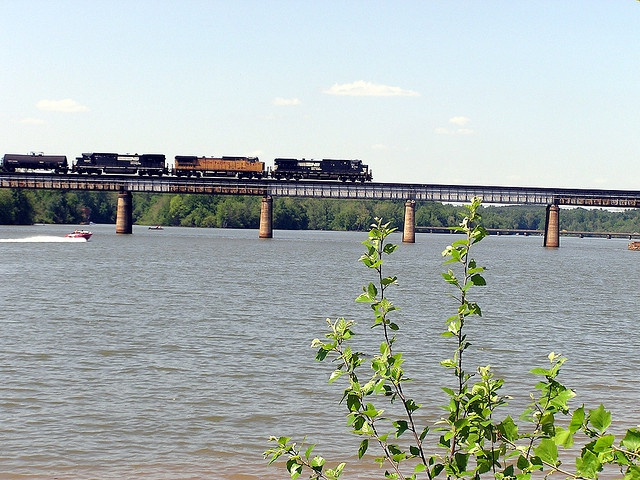Describe the objects in this image and their specific colors. I can see train in lavender, black, gray, navy, and lightgray tones, boat in lavender, white, darkgray, lightpink, and black tones, boat in lavender, gray, and tan tones, and boat in lavender, gray, black, and purple tones in this image. 